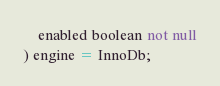Convert code to text. <code><loc_0><loc_0><loc_500><loc_500><_SQL_>    enabled boolean not null
) engine = InnoDb;</code> 